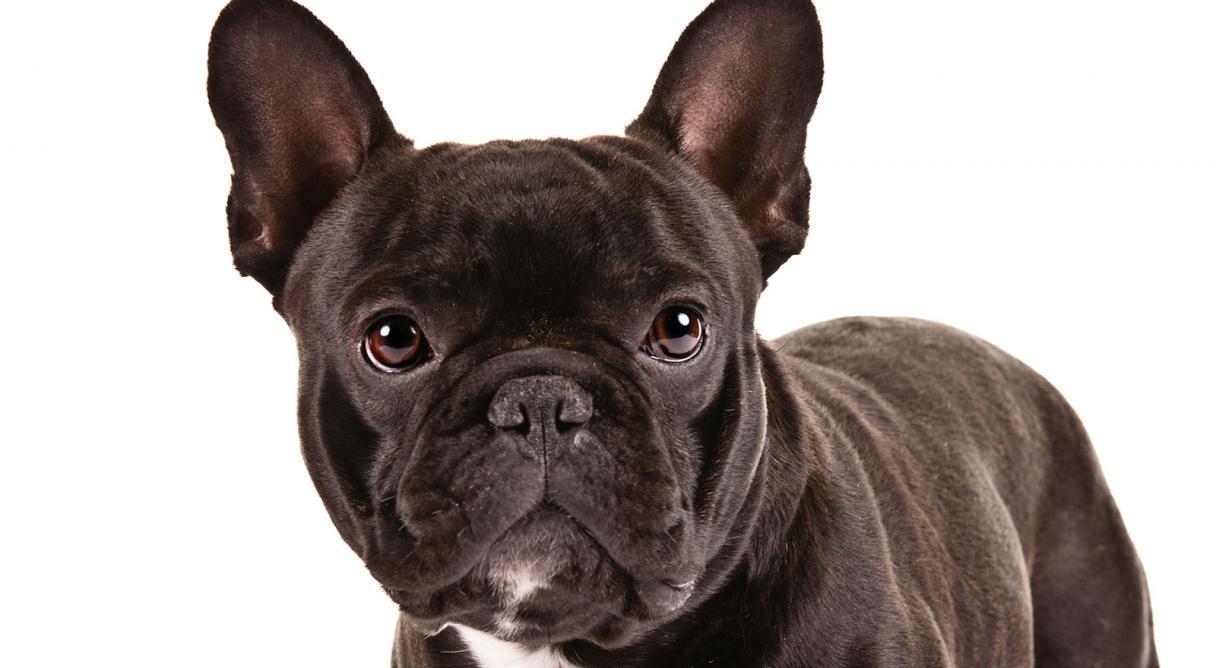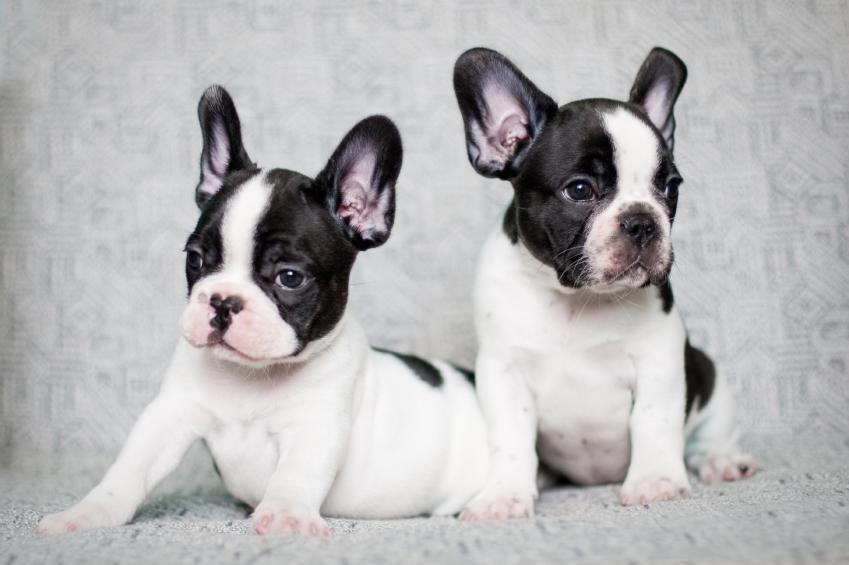The first image is the image on the left, the second image is the image on the right. For the images shown, is this caption "One tan dog and one black and white dog are shown." true? Answer yes or no. No. The first image is the image on the left, the second image is the image on the right. For the images shown, is this caption "There are 2 dogs with heads pointed up." true? Answer yes or no. No. 